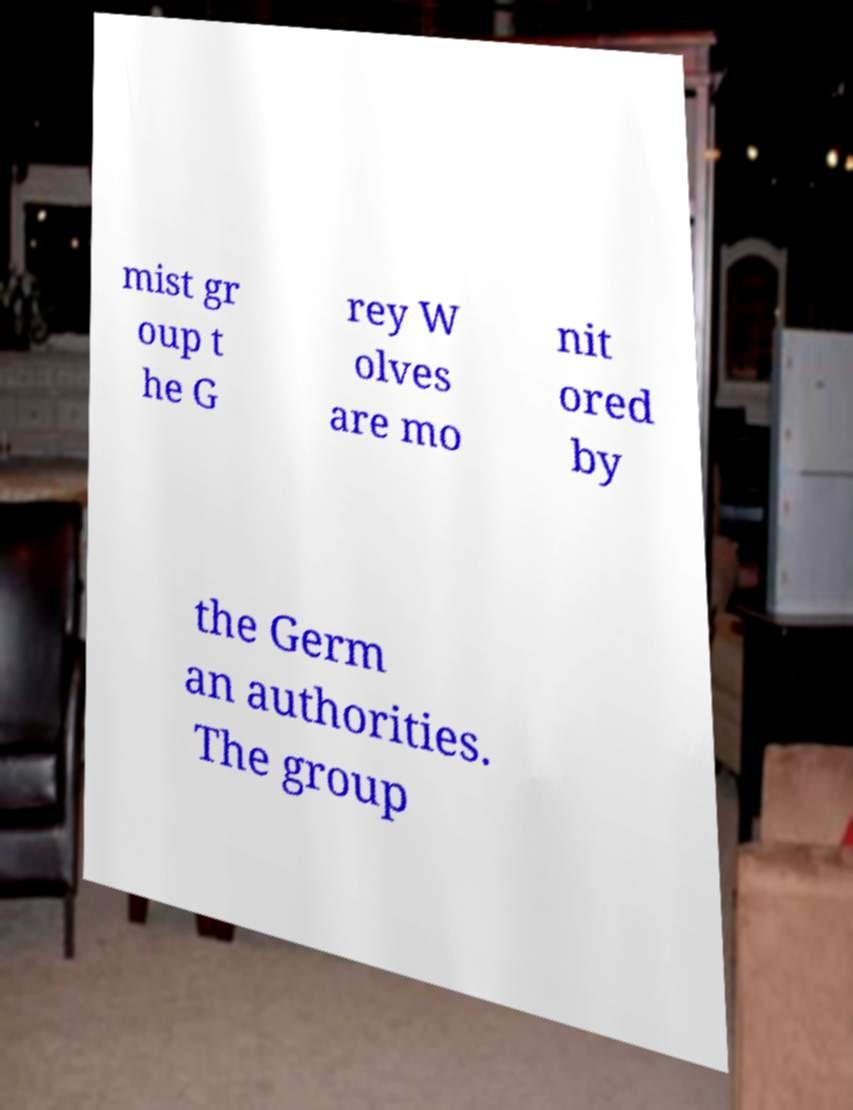For documentation purposes, I need the text within this image transcribed. Could you provide that? mist gr oup t he G rey W olves are mo nit ored by the Germ an authorities. The group 